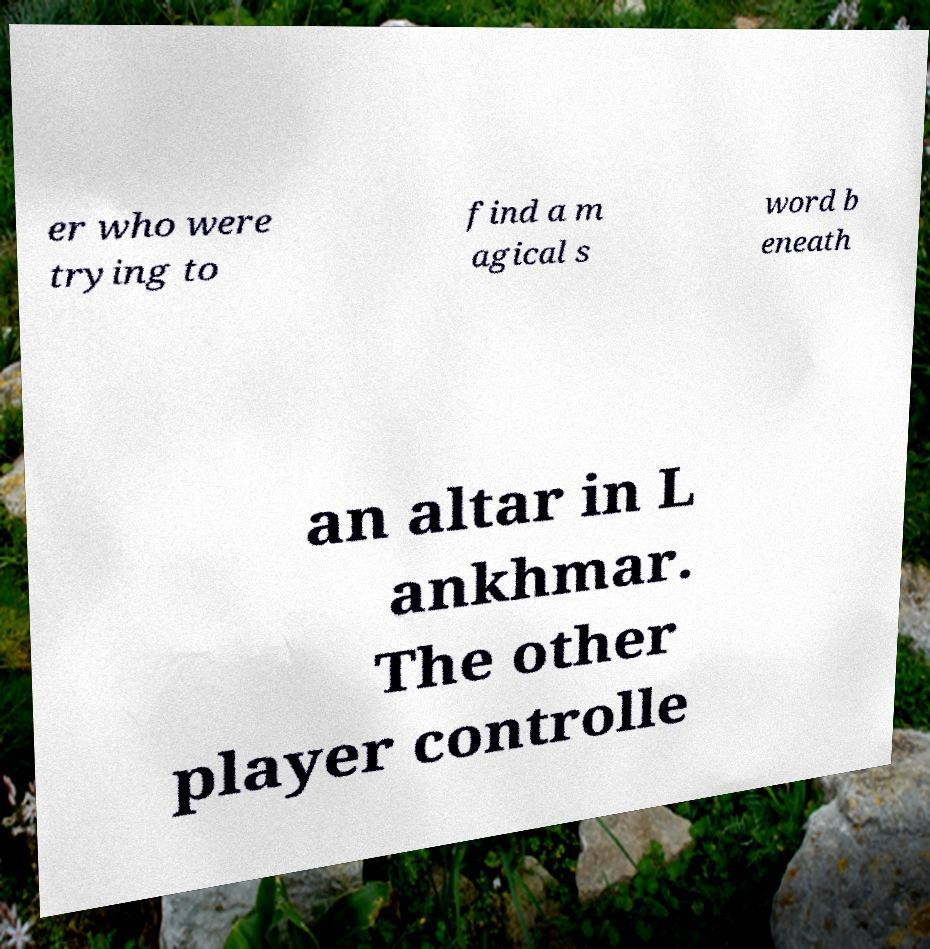Please identify and transcribe the text found in this image. er who were trying to find a m agical s word b eneath an altar in L ankhmar. The other player controlle 